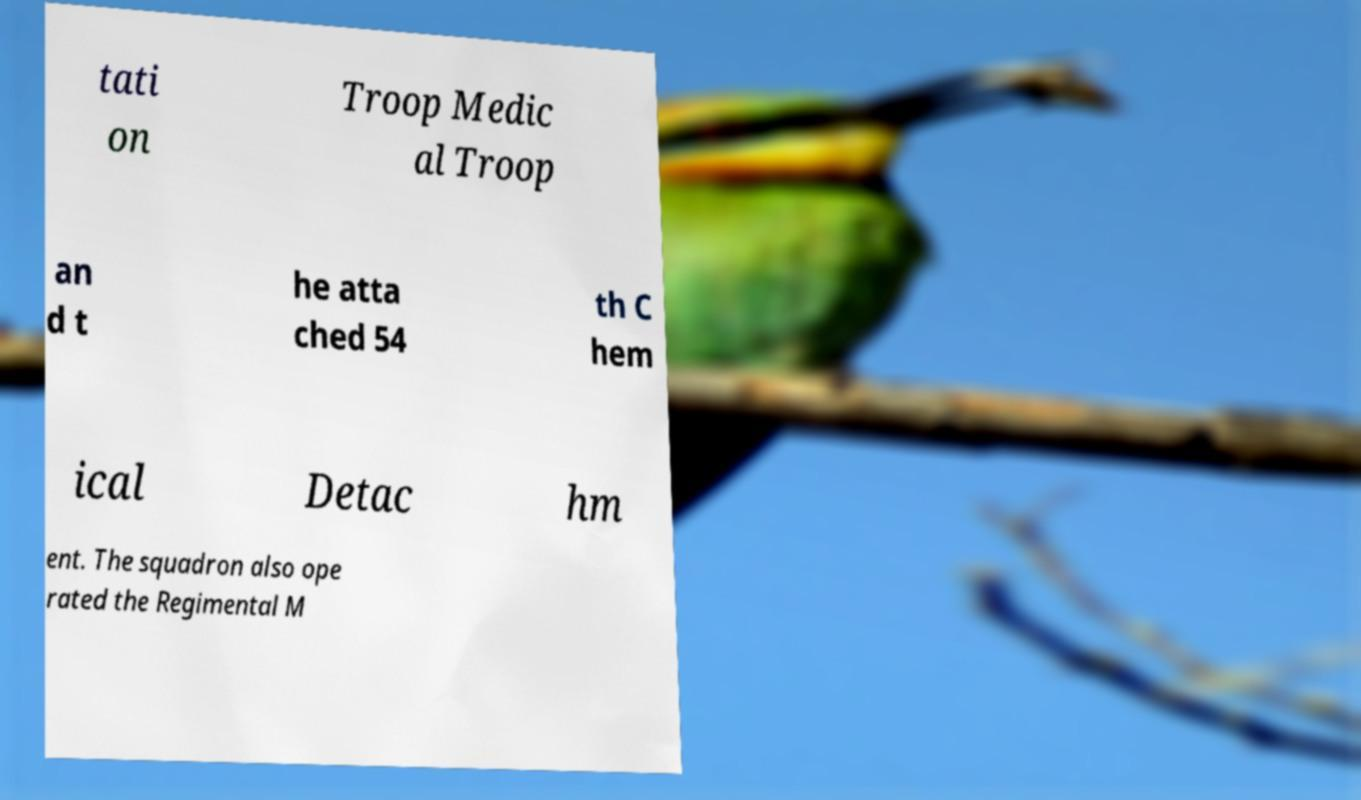Can you read and provide the text displayed in the image?This photo seems to have some interesting text. Can you extract and type it out for me? tati on Troop Medic al Troop an d t he atta ched 54 th C hem ical Detac hm ent. The squadron also ope rated the Regimental M 